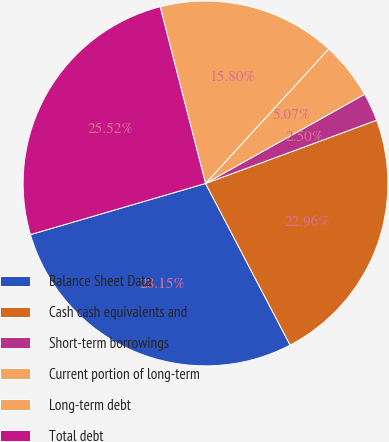Convert chart. <chart><loc_0><loc_0><loc_500><loc_500><pie_chart><fcel>Balance Sheet Data<fcel>Cash cash equivalents and<fcel>Short-term borrowings<fcel>Current portion of long-term<fcel>Long-term debt<fcel>Total debt<nl><fcel>28.15%<fcel>22.96%<fcel>2.5%<fcel>5.07%<fcel>15.8%<fcel>25.52%<nl></chart> 